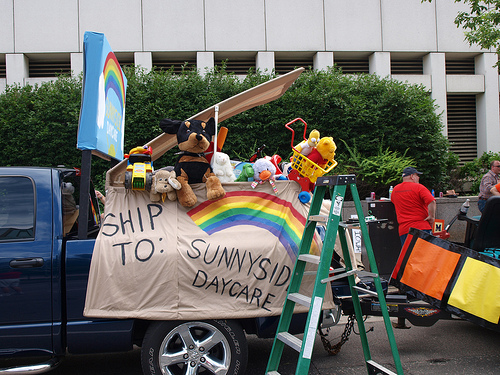<image>
Is there a tar on the vehicle? Yes. Looking at the image, I can see the tar is positioned on top of the vehicle, with the vehicle providing support. Is there a truck behind the man? No. The truck is not behind the man. From this viewpoint, the truck appears to be positioned elsewhere in the scene. 